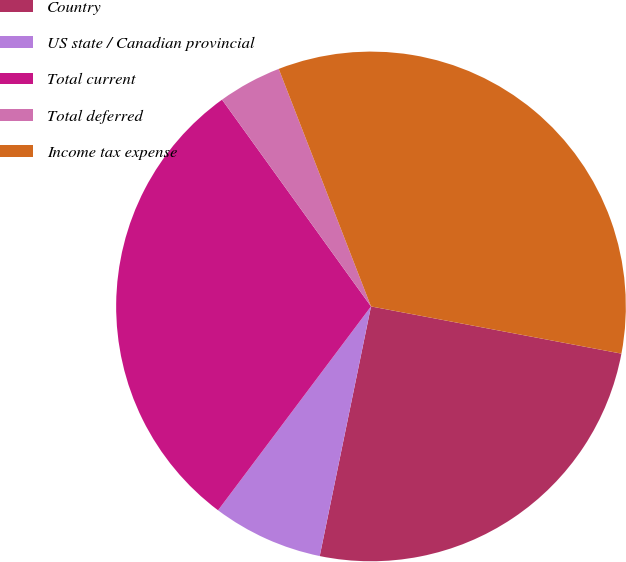<chart> <loc_0><loc_0><loc_500><loc_500><pie_chart><fcel>Country<fcel>US state / Canadian provincial<fcel>Total current<fcel>Total deferred<fcel>Income tax expense<nl><fcel>25.26%<fcel>7.02%<fcel>29.82%<fcel>4.04%<fcel>33.86%<nl></chart> 